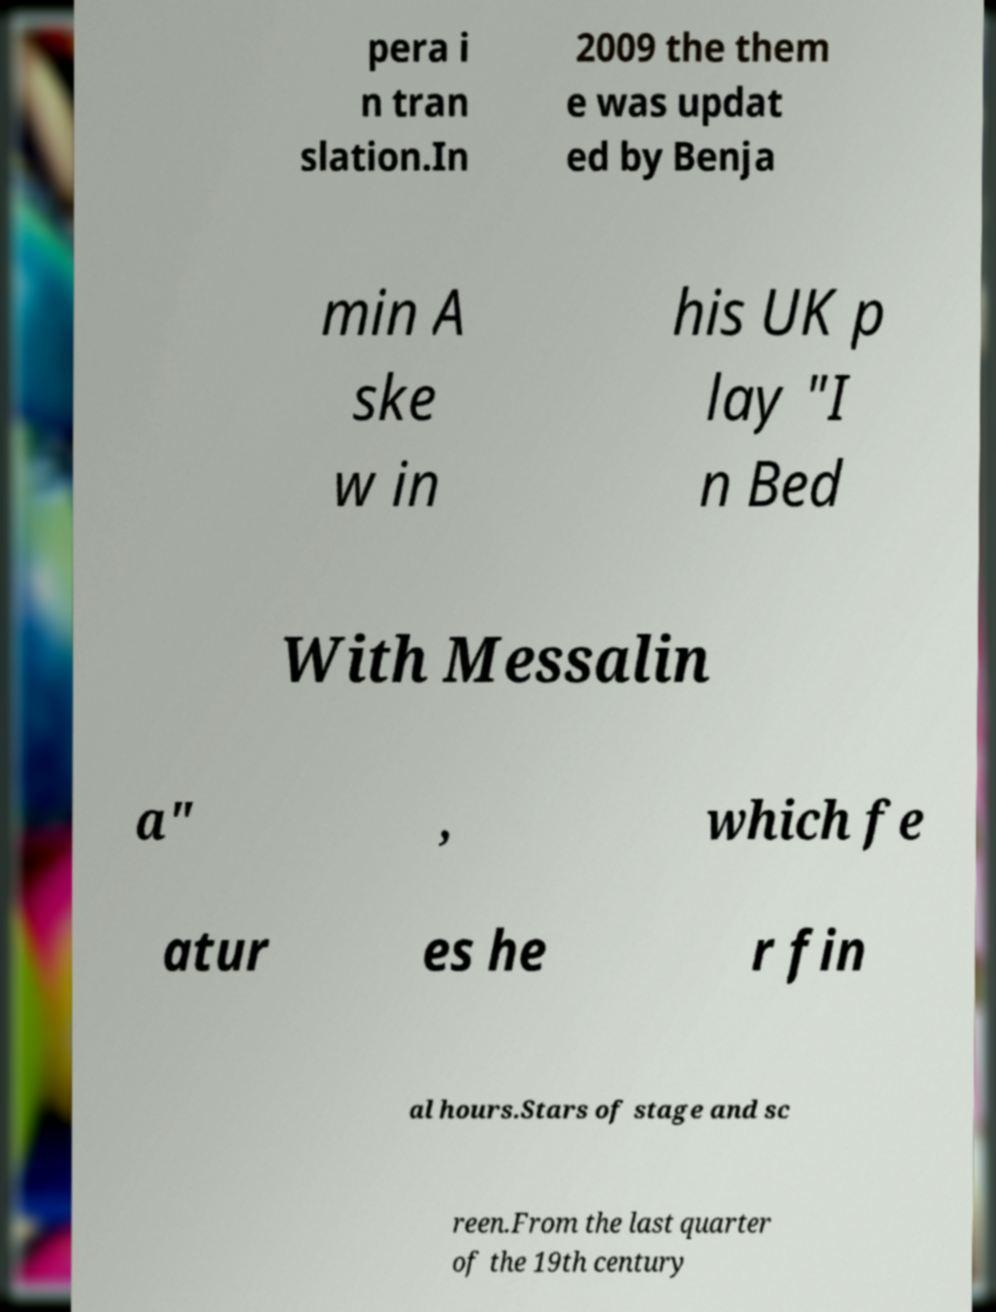Could you extract and type out the text from this image? pera i n tran slation.In 2009 the them e was updat ed by Benja min A ske w in his UK p lay "I n Bed With Messalin a" , which fe atur es he r fin al hours.Stars of stage and sc reen.From the last quarter of the 19th century 